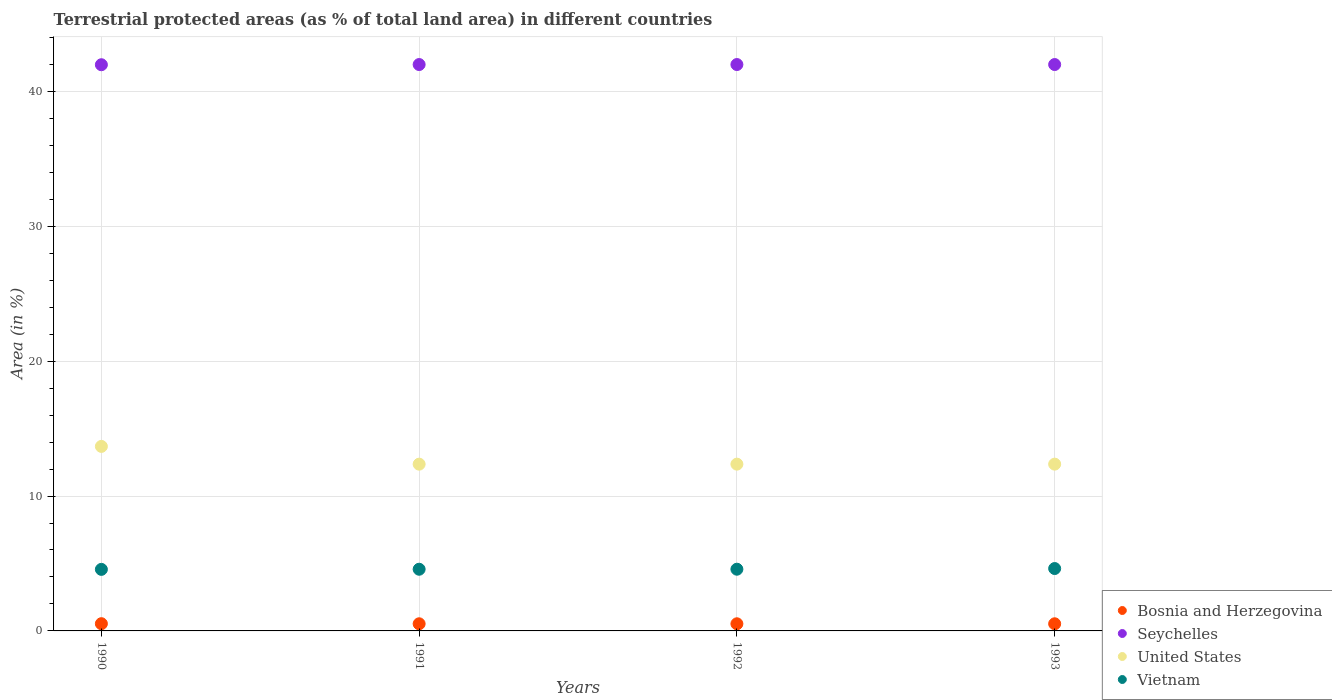How many different coloured dotlines are there?
Give a very brief answer. 4. Is the number of dotlines equal to the number of legend labels?
Provide a succinct answer. Yes. What is the percentage of terrestrial protected land in Seychelles in 1992?
Provide a succinct answer. 41.99. Across all years, what is the maximum percentage of terrestrial protected land in Seychelles?
Your response must be concise. 41.99. Across all years, what is the minimum percentage of terrestrial protected land in Seychelles?
Keep it short and to the point. 41.98. In which year was the percentage of terrestrial protected land in Vietnam maximum?
Provide a short and direct response. 1993. In which year was the percentage of terrestrial protected land in United States minimum?
Offer a very short reply. 1991. What is the total percentage of terrestrial protected land in Vietnam in the graph?
Your answer should be very brief. 18.34. What is the difference between the percentage of terrestrial protected land in Bosnia and Herzegovina in 1991 and that in 1993?
Your answer should be compact. 0. What is the difference between the percentage of terrestrial protected land in Vietnam in 1993 and the percentage of terrestrial protected land in Seychelles in 1991?
Keep it short and to the point. -37.37. What is the average percentage of terrestrial protected land in Vietnam per year?
Offer a very short reply. 4.58. In the year 1992, what is the difference between the percentage of terrestrial protected land in Bosnia and Herzegovina and percentage of terrestrial protected land in Seychelles?
Your answer should be compact. -41.46. What is the ratio of the percentage of terrestrial protected land in Seychelles in 1992 to that in 1993?
Offer a terse response. 1. What is the difference between the highest and the second highest percentage of terrestrial protected land in Seychelles?
Offer a very short reply. 0. What is the difference between the highest and the lowest percentage of terrestrial protected land in Seychelles?
Provide a succinct answer. 0.01. In how many years, is the percentage of terrestrial protected land in Vietnam greater than the average percentage of terrestrial protected land in Vietnam taken over all years?
Make the answer very short. 1. Is it the case that in every year, the sum of the percentage of terrestrial protected land in United States and percentage of terrestrial protected land in Seychelles  is greater than the percentage of terrestrial protected land in Vietnam?
Provide a succinct answer. Yes. Is the percentage of terrestrial protected land in United States strictly less than the percentage of terrestrial protected land in Vietnam over the years?
Offer a terse response. No. How many years are there in the graph?
Make the answer very short. 4. What is the difference between two consecutive major ticks on the Y-axis?
Your response must be concise. 10. Does the graph contain any zero values?
Your answer should be compact. No. How are the legend labels stacked?
Your response must be concise. Vertical. What is the title of the graph?
Offer a terse response. Terrestrial protected areas (as % of total land area) in different countries. Does "Switzerland" appear as one of the legend labels in the graph?
Provide a succinct answer. No. What is the label or title of the X-axis?
Ensure brevity in your answer.  Years. What is the label or title of the Y-axis?
Ensure brevity in your answer.  Area (in %). What is the Area (in %) of Bosnia and Herzegovina in 1990?
Provide a succinct answer. 0.54. What is the Area (in %) in Seychelles in 1990?
Your answer should be compact. 41.98. What is the Area (in %) in United States in 1990?
Ensure brevity in your answer.  13.68. What is the Area (in %) in Vietnam in 1990?
Provide a short and direct response. 4.56. What is the Area (in %) in Bosnia and Herzegovina in 1991?
Offer a very short reply. 0.53. What is the Area (in %) of Seychelles in 1991?
Keep it short and to the point. 41.99. What is the Area (in %) in United States in 1991?
Make the answer very short. 12.36. What is the Area (in %) of Vietnam in 1991?
Offer a very short reply. 4.57. What is the Area (in %) of Bosnia and Herzegovina in 1992?
Offer a very short reply. 0.53. What is the Area (in %) of Seychelles in 1992?
Ensure brevity in your answer.  41.99. What is the Area (in %) in United States in 1992?
Give a very brief answer. 12.36. What is the Area (in %) of Vietnam in 1992?
Offer a very short reply. 4.57. What is the Area (in %) in Bosnia and Herzegovina in 1993?
Make the answer very short. 0.53. What is the Area (in %) of Seychelles in 1993?
Ensure brevity in your answer.  41.99. What is the Area (in %) in United States in 1993?
Your answer should be compact. 12.37. What is the Area (in %) in Vietnam in 1993?
Offer a terse response. 4.63. Across all years, what is the maximum Area (in %) in Bosnia and Herzegovina?
Provide a short and direct response. 0.54. Across all years, what is the maximum Area (in %) of Seychelles?
Offer a terse response. 41.99. Across all years, what is the maximum Area (in %) in United States?
Provide a short and direct response. 13.68. Across all years, what is the maximum Area (in %) of Vietnam?
Give a very brief answer. 4.63. Across all years, what is the minimum Area (in %) in Bosnia and Herzegovina?
Provide a succinct answer. 0.53. Across all years, what is the minimum Area (in %) in Seychelles?
Offer a terse response. 41.98. Across all years, what is the minimum Area (in %) in United States?
Your answer should be compact. 12.36. Across all years, what is the minimum Area (in %) of Vietnam?
Give a very brief answer. 4.56. What is the total Area (in %) of Bosnia and Herzegovina in the graph?
Ensure brevity in your answer.  2.12. What is the total Area (in %) in Seychelles in the graph?
Provide a succinct answer. 167.95. What is the total Area (in %) in United States in the graph?
Your response must be concise. 50.77. What is the total Area (in %) of Vietnam in the graph?
Offer a terse response. 18.34. What is the difference between the Area (in %) in Bosnia and Herzegovina in 1990 and that in 1991?
Offer a terse response. 0.01. What is the difference between the Area (in %) in Seychelles in 1990 and that in 1991?
Keep it short and to the point. -0.01. What is the difference between the Area (in %) in United States in 1990 and that in 1991?
Give a very brief answer. 1.32. What is the difference between the Area (in %) in Vietnam in 1990 and that in 1991?
Provide a short and direct response. -0.01. What is the difference between the Area (in %) in Bosnia and Herzegovina in 1990 and that in 1992?
Provide a succinct answer. 0.01. What is the difference between the Area (in %) in Seychelles in 1990 and that in 1992?
Provide a short and direct response. -0.01. What is the difference between the Area (in %) of United States in 1990 and that in 1992?
Keep it short and to the point. 1.32. What is the difference between the Area (in %) in Vietnam in 1990 and that in 1992?
Provide a short and direct response. -0.01. What is the difference between the Area (in %) in Bosnia and Herzegovina in 1990 and that in 1993?
Offer a very short reply. 0.01. What is the difference between the Area (in %) of Seychelles in 1990 and that in 1993?
Offer a terse response. -0.01. What is the difference between the Area (in %) of United States in 1990 and that in 1993?
Provide a short and direct response. 1.31. What is the difference between the Area (in %) of Vietnam in 1990 and that in 1993?
Your answer should be very brief. -0.06. What is the difference between the Area (in %) in United States in 1991 and that in 1992?
Your response must be concise. -0. What is the difference between the Area (in %) of Vietnam in 1991 and that in 1992?
Ensure brevity in your answer.  -0. What is the difference between the Area (in %) of United States in 1991 and that in 1993?
Your response must be concise. -0. What is the difference between the Area (in %) in Vietnam in 1991 and that in 1993?
Keep it short and to the point. -0.05. What is the difference between the Area (in %) in Bosnia and Herzegovina in 1992 and that in 1993?
Offer a very short reply. 0. What is the difference between the Area (in %) of Seychelles in 1992 and that in 1993?
Ensure brevity in your answer.  0. What is the difference between the Area (in %) in United States in 1992 and that in 1993?
Offer a very short reply. -0. What is the difference between the Area (in %) of Vietnam in 1992 and that in 1993?
Make the answer very short. -0.05. What is the difference between the Area (in %) in Bosnia and Herzegovina in 1990 and the Area (in %) in Seychelles in 1991?
Give a very brief answer. -41.46. What is the difference between the Area (in %) in Bosnia and Herzegovina in 1990 and the Area (in %) in United States in 1991?
Make the answer very short. -11.83. What is the difference between the Area (in %) of Bosnia and Herzegovina in 1990 and the Area (in %) of Vietnam in 1991?
Offer a very short reply. -4.04. What is the difference between the Area (in %) in Seychelles in 1990 and the Area (in %) in United States in 1991?
Your response must be concise. 29.61. What is the difference between the Area (in %) of Seychelles in 1990 and the Area (in %) of Vietnam in 1991?
Provide a short and direct response. 37.4. What is the difference between the Area (in %) in United States in 1990 and the Area (in %) in Vietnam in 1991?
Give a very brief answer. 9.11. What is the difference between the Area (in %) in Bosnia and Herzegovina in 1990 and the Area (in %) in Seychelles in 1992?
Your answer should be very brief. -41.46. What is the difference between the Area (in %) in Bosnia and Herzegovina in 1990 and the Area (in %) in United States in 1992?
Provide a succinct answer. -11.83. What is the difference between the Area (in %) in Bosnia and Herzegovina in 1990 and the Area (in %) in Vietnam in 1992?
Offer a terse response. -4.04. What is the difference between the Area (in %) in Seychelles in 1990 and the Area (in %) in United States in 1992?
Your answer should be very brief. 29.61. What is the difference between the Area (in %) in Seychelles in 1990 and the Area (in %) in Vietnam in 1992?
Make the answer very short. 37.4. What is the difference between the Area (in %) of United States in 1990 and the Area (in %) of Vietnam in 1992?
Provide a short and direct response. 9.11. What is the difference between the Area (in %) in Bosnia and Herzegovina in 1990 and the Area (in %) in Seychelles in 1993?
Ensure brevity in your answer.  -41.46. What is the difference between the Area (in %) of Bosnia and Herzegovina in 1990 and the Area (in %) of United States in 1993?
Your answer should be compact. -11.83. What is the difference between the Area (in %) of Bosnia and Herzegovina in 1990 and the Area (in %) of Vietnam in 1993?
Ensure brevity in your answer.  -4.09. What is the difference between the Area (in %) of Seychelles in 1990 and the Area (in %) of United States in 1993?
Offer a very short reply. 29.61. What is the difference between the Area (in %) in Seychelles in 1990 and the Area (in %) in Vietnam in 1993?
Your answer should be very brief. 37.35. What is the difference between the Area (in %) of United States in 1990 and the Area (in %) of Vietnam in 1993?
Give a very brief answer. 9.05. What is the difference between the Area (in %) in Bosnia and Herzegovina in 1991 and the Area (in %) in Seychelles in 1992?
Offer a very short reply. -41.46. What is the difference between the Area (in %) in Bosnia and Herzegovina in 1991 and the Area (in %) in United States in 1992?
Offer a very short reply. -11.84. What is the difference between the Area (in %) in Bosnia and Herzegovina in 1991 and the Area (in %) in Vietnam in 1992?
Ensure brevity in your answer.  -4.05. What is the difference between the Area (in %) of Seychelles in 1991 and the Area (in %) of United States in 1992?
Your answer should be compact. 29.63. What is the difference between the Area (in %) of Seychelles in 1991 and the Area (in %) of Vietnam in 1992?
Offer a very short reply. 37.42. What is the difference between the Area (in %) of United States in 1991 and the Area (in %) of Vietnam in 1992?
Make the answer very short. 7.79. What is the difference between the Area (in %) in Bosnia and Herzegovina in 1991 and the Area (in %) in Seychelles in 1993?
Make the answer very short. -41.46. What is the difference between the Area (in %) in Bosnia and Herzegovina in 1991 and the Area (in %) in United States in 1993?
Your answer should be very brief. -11.84. What is the difference between the Area (in %) in Bosnia and Herzegovina in 1991 and the Area (in %) in Vietnam in 1993?
Make the answer very short. -4.1. What is the difference between the Area (in %) in Seychelles in 1991 and the Area (in %) in United States in 1993?
Your answer should be compact. 29.63. What is the difference between the Area (in %) in Seychelles in 1991 and the Area (in %) in Vietnam in 1993?
Ensure brevity in your answer.  37.37. What is the difference between the Area (in %) of United States in 1991 and the Area (in %) of Vietnam in 1993?
Your answer should be compact. 7.74. What is the difference between the Area (in %) in Bosnia and Herzegovina in 1992 and the Area (in %) in Seychelles in 1993?
Give a very brief answer. -41.46. What is the difference between the Area (in %) of Bosnia and Herzegovina in 1992 and the Area (in %) of United States in 1993?
Provide a succinct answer. -11.84. What is the difference between the Area (in %) of Bosnia and Herzegovina in 1992 and the Area (in %) of Vietnam in 1993?
Offer a terse response. -4.1. What is the difference between the Area (in %) of Seychelles in 1992 and the Area (in %) of United States in 1993?
Your answer should be very brief. 29.63. What is the difference between the Area (in %) in Seychelles in 1992 and the Area (in %) in Vietnam in 1993?
Ensure brevity in your answer.  37.37. What is the difference between the Area (in %) in United States in 1992 and the Area (in %) in Vietnam in 1993?
Provide a short and direct response. 7.74. What is the average Area (in %) of Bosnia and Herzegovina per year?
Give a very brief answer. 0.53. What is the average Area (in %) of Seychelles per year?
Your answer should be very brief. 41.99. What is the average Area (in %) in United States per year?
Your response must be concise. 12.69. What is the average Area (in %) in Vietnam per year?
Your response must be concise. 4.58. In the year 1990, what is the difference between the Area (in %) of Bosnia and Herzegovina and Area (in %) of Seychelles?
Ensure brevity in your answer.  -41.44. In the year 1990, what is the difference between the Area (in %) of Bosnia and Herzegovina and Area (in %) of United States?
Make the answer very short. -13.14. In the year 1990, what is the difference between the Area (in %) of Bosnia and Herzegovina and Area (in %) of Vietnam?
Provide a succinct answer. -4.03. In the year 1990, what is the difference between the Area (in %) in Seychelles and Area (in %) in United States?
Make the answer very short. 28.3. In the year 1990, what is the difference between the Area (in %) in Seychelles and Area (in %) in Vietnam?
Offer a very short reply. 37.41. In the year 1990, what is the difference between the Area (in %) of United States and Area (in %) of Vietnam?
Offer a very short reply. 9.12. In the year 1991, what is the difference between the Area (in %) of Bosnia and Herzegovina and Area (in %) of Seychelles?
Give a very brief answer. -41.46. In the year 1991, what is the difference between the Area (in %) in Bosnia and Herzegovina and Area (in %) in United States?
Your answer should be very brief. -11.83. In the year 1991, what is the difference between the Area (in %) in Bosnia and Herzegovina and Area (in %) in Vietnam?
Keep it short and to the point. -4.04. In the year 1991, what is the difference between the Area (in %) in Seychelles and Area (in %) in United States?
Provide a short and direct response. 29.63. In the year 1991, what is the difference between the Area (in %) in Seychelles and Area (in %) in Vietnam?
Make the answer very short. 37.42. In the year 1991, what is the difference between the Area (in %) in United States and Area (in %) in Vietnam?
Offer a terse response. 7.79. In the year 1992, what is the difference between the Area (in %) of Bosnia and Herzegovina and Area (in %) of Seychelles?
Offer a very short reply. -41.46. In the year 1992, what is the difference between the Area (in %) in Bosnia and Herzegovina and Area (in %) in United States?
Make the answer very short. -11.84. In the year 1992, what is the difference between the Area (in %) in Bosnia and Herzegovina and Area (in %) in Vietnam?
Offer a very short reply. -4.05. In the year 1992, what is the difference between the Area (in %) of Seychelles and Area (in %) of United States?
Offer a very short reply. 29.63. In the year 1992, what is the difference between the Area (in %) of Seychelles and Area (in %) of Vietnam?
Give a very brief answer. 37.42. In the year 1992, what is the difference between the Area (in %) in United States and Area (in %) in Vietnam?
Provide a short and direct response. 7.79. In the year 1993, what is the difference between the Area (in %) in Bosnia and Herzegovina and Area (in %) in Seychelles?
Give a very brief answer. -41.46. In the year 1993, what is the difference between the Area (in %) of Bosnia and Herzegovina and Area (in %) of United States?
Provide a succinct answer. -11.84. In the year 1993, what is the difference between the Area (in %) in Bosnia and Herzegovina and Area (in %) in Vietnam?
Ensure brevity in your answer.  -4.1. In the year 1993, what is the difference between the Area (in %) in Seychelles and Area (in %) in United States?
Provide a succinct answer. 29.63. In the year 1993, what is the difference between the Area (in %) in Seychelles and Area (in %) in Vietnam?
Ensure brevity in your answer.  37.37. In the year 1993, what is the difference between the Area (in %) of United States and Area (in %) of Vietnam?
Ensure brevity in your answer.  7.74. What is the ratio of the Area (in %) of Bosnia and Herzegovina in 1990 to that in 1991?
Your answer should be compact. 1.01. What is the ratio of the Area (in %) of United States in 1990 to that in 1991?
Your answer should be very brief. 1.11. What is the ratio of the Area (in %) in Vietnam in 1990 to that in 1991?
Your answer should be very brief. 1. What is the ratio of the Area (in %) in Bosnia and Herzegovina in 1990 to that in 1992?
Make the answer very short. 1.01. What is the ratio of the Area (in %) in Seychelles in 1990 to that in 1992?
Offer a very short reply. 1. What is the ratio of the Area (in %) of United States in 1990 to that in 1992?
Keep it short and to the point. 1.11. What is the ratio of the Area (in %) in Vietnam in 1990 to that in 1992?
Give a very brief answer. 1. What is the ratio of the Area (in %) in Bosnia and Herzegovina in 1990 to that in 1993?
Provide a short and direct response. 1.01. What is the ratio of the Area (in %) of United States in 1990 to that in 1993?
Provide a succinct answer. 1.11. What is the ratio of the Area (in %) in Vietnam in 1990 to that in 1993?
Offer a very short reply. 0.99. What is the ratio of the Area (in %) in Bosnia and Herzegovina in 1991 to that in 1992?
Offer a very short reply. 1. What is the ratio of the Area (in %) in Seychelles in 1991 to that in 1992?
Make the answer very short. 1. What is the ratio of the Area (in %) in United States in 1991 to that in 1992?
Give a very brief answer. 1. What is the ratio of the Area (in %) in Vietnam in 1991 to that in 1992?
Offer a terse response. 1. What is the ratio of the Area (in %) in United States in 1991 to that in 1993?
Provide a succinct answer. 1. What is the ratio of the Area (in %) of Vietnam in 1991 to that in 1993?
Keep it short and to the point. 0.99. What is the ratio of the Area (in %) in Bosnia and Herzegovina in 1992 to that in 1993?
Offer a very short reply. 1. What is the difference between the highest and the second highest Area (in %) in Bosnia and Herzegovina?
Make the answer very short. 0.01. What is the difference between the highest and the second highest Area (in %) of Seychelles?
Make the answer very short. 0. What is the difference between the highest and the second highest Area (in %) of United States?
Offer a very short reply. 1.31. What is the difference between the highest and the second highest Area (in %) of Vietnam?
Offer a terse response. 0.05. What is the difference between the highest and the lowest Area (in %) in Bosnia and Herzegovina?
Ensure brevity in your answer.  0.01. What is the difference between the highest and the lowest Area (in %) of Seychelles?
Your response must be concise. 0.01. What is the difference between the highest and the lowest Area (in %) in United States?
Your answer should be very brief. 1.32. What is the difference between the highest and the lowest Area (in %) in Vietnam?
Give a very brief answer. 0.06. 